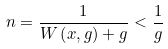<formula> <loc_0><loc_0><loc_500><loc_500>n = \frac { 1 } { W \left ( x , g \right ) + g } < \frac { 1 } { g }</formula> 